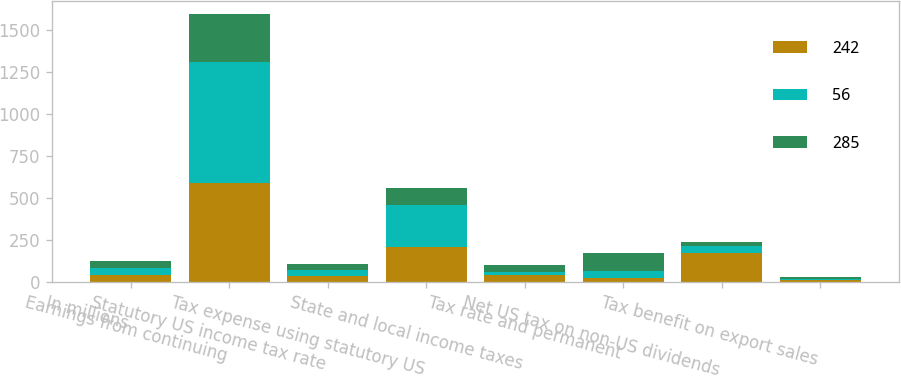Convert chart to OTSL. <chart><loc_0><loc_0><loc_500><loc_500><stacked_bar_chart><ecel><fcel>In millions<fcel>Earnings from continuing<fcel>Statutory US income tax rate<fcel>Tax expense using statutory US<fcel>State and local income taxes<fcel>Tax rate and permanent<fcel>Net US tax on non-US dividends<fcel>Tax benefit on export sales<nl><fcel>242<fcel>41<fcel>586<fcel>35<fcel>205<fcel>41<fcel>25<fcel>169<fcel>9<nl><fcel>56<fcel>41<fcel>724<fcel>35<fcel>253<fcel>19<fcel>41<fcel>44<fcel>7<nl><fcel>285<fcel>41<fcel>285<fcel>35<fcel>100<fcel>41<fcel>105<fcel>26<fcel>12<nl></chart> 